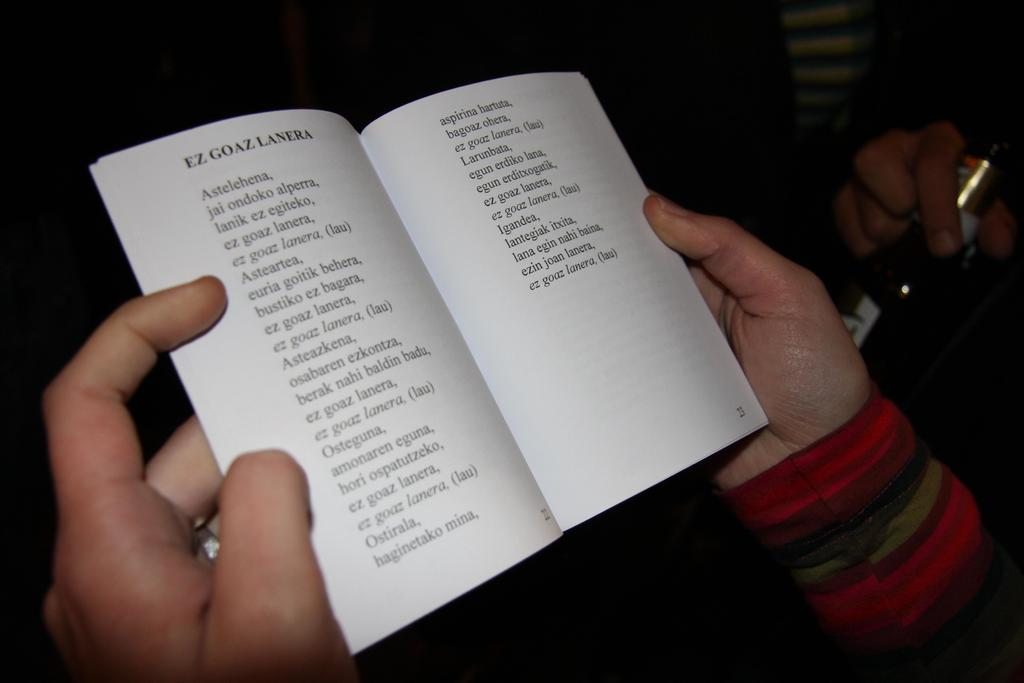<image>
Describe the image concisely. Person holding an open book with the words "Ez Goaz Lanera" on top. 